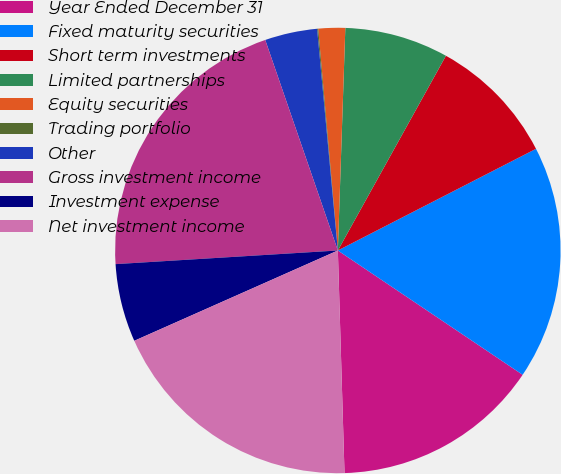Convert chart. <chart><loc_0><loc_0><loc_500><loc_500><pie_chart><fcel>Year Ended December 31<fcel>Fixed maturity securities<fcel>Short term investments<fcel>Limited partnerships<fcel>Equity securities<fcel>Trading portfolio<fcel>Other<fcel>Gross investment income<fcel>Investment expense<fcel>Net investment income<nl><fcel>15.1%<fcel>16.97%<fcel>9.39%<fcel>7.53%<fcel>1.94%<fcel>0.08%<fcel>3.8%<fcel>20.69%<fcel>5.67%<fcel>18.83%<nl></chart> 